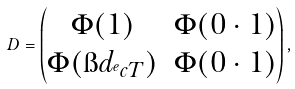<formula> <loc_0><loc_0><loc_500><loc_500>D = \begin{pmatrix} \Phi ( 1 ) & \Phi ( 0 \cdot 1 ) \\ \Phi ( \i d _ { ^ { e } c T } ) & \Phi ( 0 \cdot 1 ) \\ \end{pmatrix} ,</formula> 